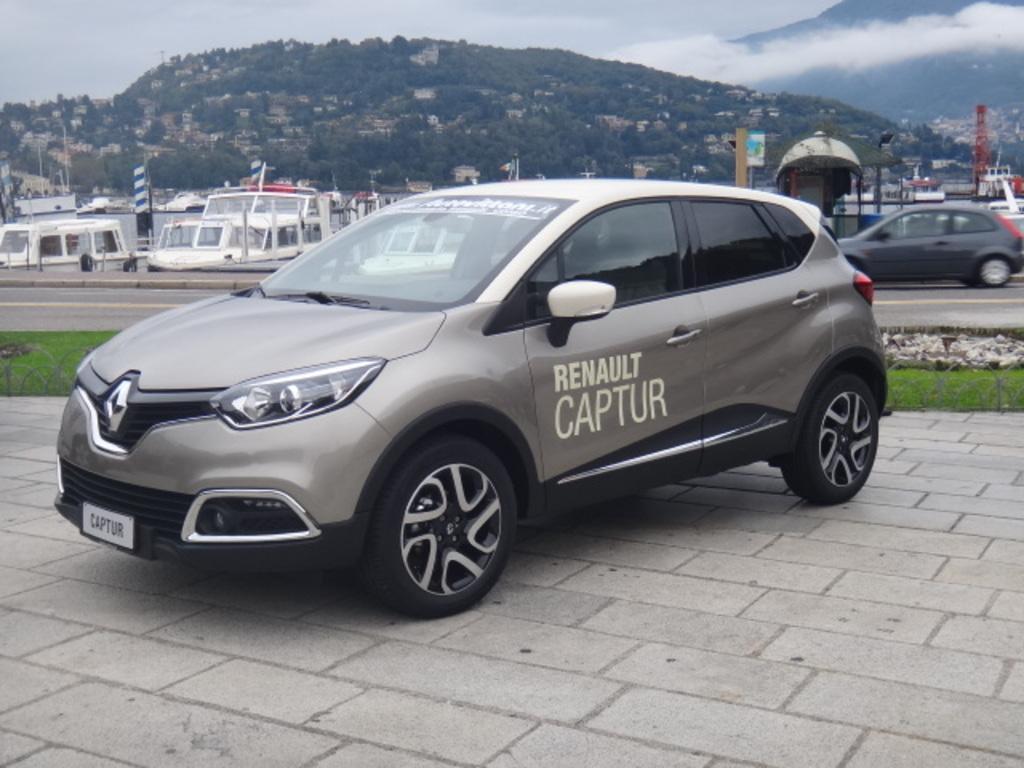Could you give a brief overview of what you see in this image? In this image we can see a car on the tiles on the ground, small fence, grass, vehicle on the ground, boats, flags, poles. In the background there are trees and buildings on the hill, mountains and clouds in the sky. 